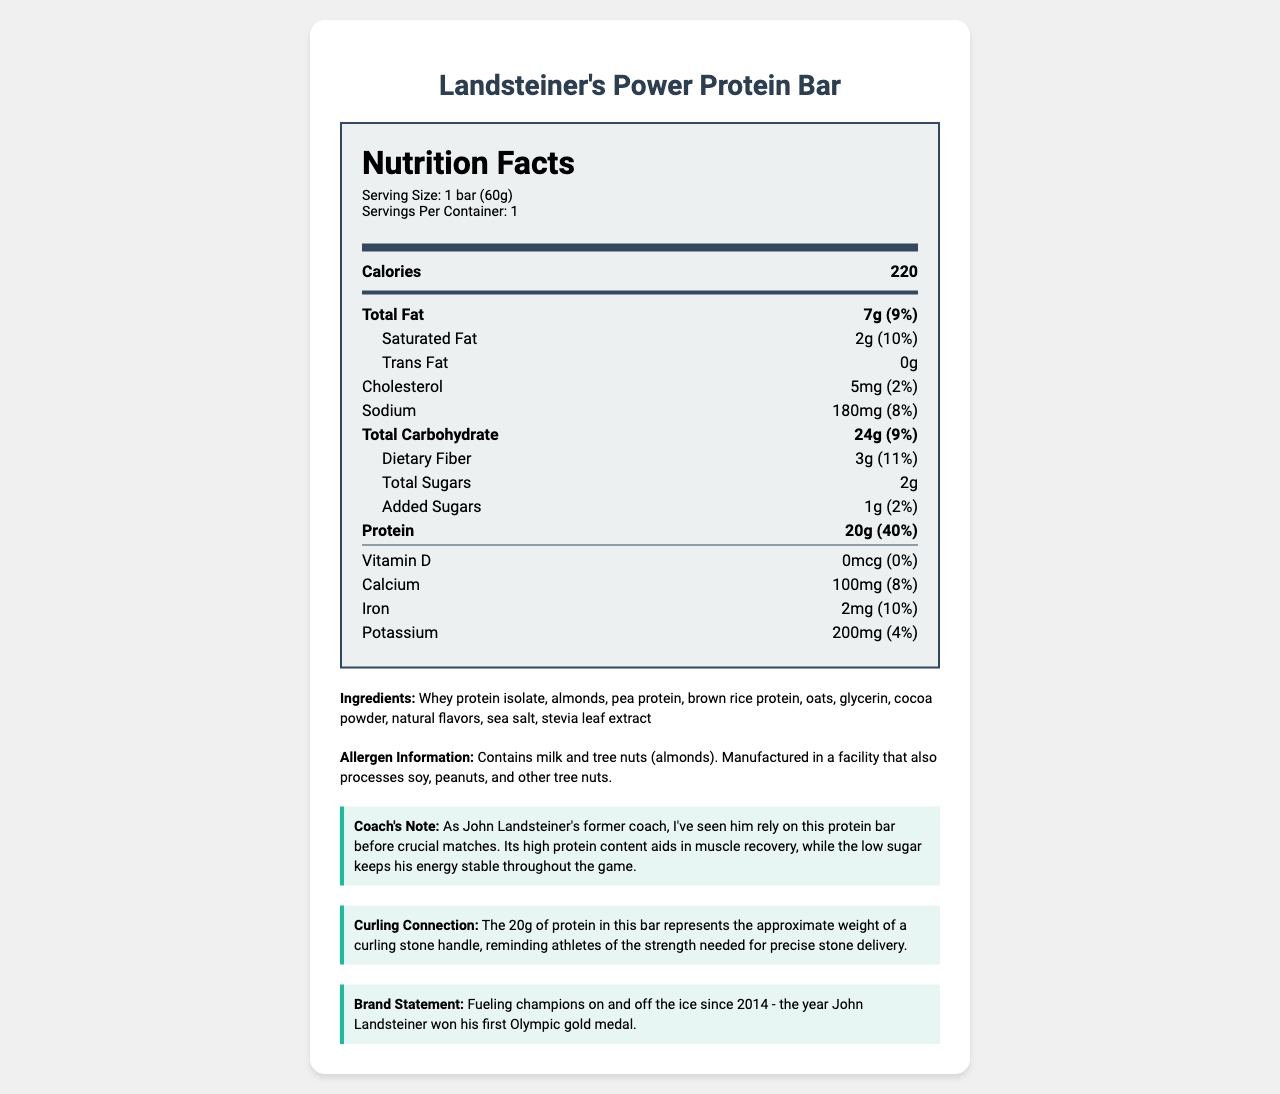what is the serving size of Landsteiner's Power Protein Bar? The serving size is mentioned under the serving info section at the top of the nutrition label.
Answer: 1 bar (60g) how much protein does one bar contain? In the nutrition label, the protein content is listed as 20g.
Answer: 20g what percentage of the daily value of protein is in one bar? The nutrition label states that one bar contains 40% of the daily value of protein.
Answer: 40% how many grams of total fat are there in one bar? The total fat content is listed as 7g in the nutrition label.
Answer: 7g what is the amount of added sugars in one bar? The nutrition label shows that the added sugars amount to 1g.
Answer: 1g what is the cholesterol content in the bar? The nutrition label lists the cholesterol content as 5mg.
Answer: 5mg what allergen information is provided? The allergen information is explicitly stated below the ingredients section of the document.
Answer: Contains milk and tree nuts (almonds). Manufactured in a facility that also processes soy, peanuts, and other tree nuts. how does the nutrition label highlight its connection to curling? This connection is noted in the "Curling Connection" section of the document.
Answer: The 20g of protein represents the approximate weight of a curling stone handle, reminding athletes of the strength needed for precise stone delivery. what is the main idea of the document? The document includes detailed nutrition information, ingredients, allergen info, coach's note, and curling-related insights.
Answer: The document provides the nutrition facts for Landsteiner's Power Protein Bar, emphasizing its high protein content and low sugar, and highlights its benefits and connection to curling. which of the following vitamins has 0% of the daily value in one bar? A. Vitamin D B. Calcium C. Iron D. Potassium The nutrition label indicates that Vitamin D has 0% of the daily value.
Answer: A. Vitamin D how many grams of dietary fiber does the bar contain? The dietary fiber content is 3g as shown in the nutrition label.
Answer: 3g what is the calorie count of Landsteiner's Power Protein Bar? The calorie count is listed as 220 in the nutrition label.
Answer: 220 true or false: the bar contains no trans fat. The nutrition label shows 0g of trans fat.
Answer: True how much sodium is in the bar? The sodium content is listed as 180mg on the nutrition label.
Answer: 180mg what year is mentioned in the brand statement? The brand statement mentions the year 2014, when John Landsteiner won his first Olympic gold medal.
Answer: 2014 what are the three main protein sources in the bar? The primary protein sources are listed in the ingredients as whey protein isolate, almonds, and pea protein.
Answer: Whey protein isolate, almonds, pea protein what minerals are listed in the nutrition label, and what are their daily values? The document lists calcium (8%), iron (10%), and potassium (4%) and their respective daily values.
Answer: Calcium (8%), Iron (10%), Potassium (4%) how is the coach's note related to John Landsteiner? This is mentioned in the section labeled "Coach's Note".
Answer: The coach's note describes how John Landsteiner relied on this protein bar before crucial matches for muscle recovery and stable energy. who manufactures Landsteiner's Power Protein Bar? The document does not provide any information about the manufacturer of the protein bar.
Answer: Cannot be determined which ingredient acts as a sweetener in the bar? A. Cocoa powder B. Stevia leaf extract C. Natural flavors D. Sea salt Stevia leaf extract is known to be a natural sweetener, listed in the ingredients.
Answer: B. Stevia leaf extract 